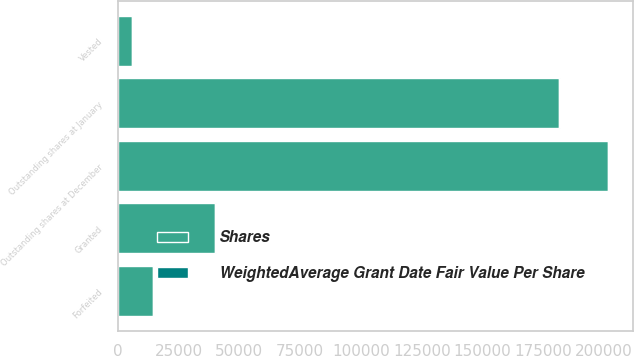<chart> <loc_0><loc_0><loc_500><loc_500><stacked_bar_chart><ecel><fcel>Outstanding shares at January<fcel>Granted<fcel>Vested<fcel>Forfeited<fcel>Outstanding shares at December<nl><fcel>Shares<fcel>181650<fcel>40170<fcel>5800<fcel>14450<fcel>201570<nl><fcel>WeightedAverage Grant Date Fair Value Per Share<fcel>74.94<fcel>79.1<fcel>73.22<fcel>79.69<fcel>75.48<nl></chart> 